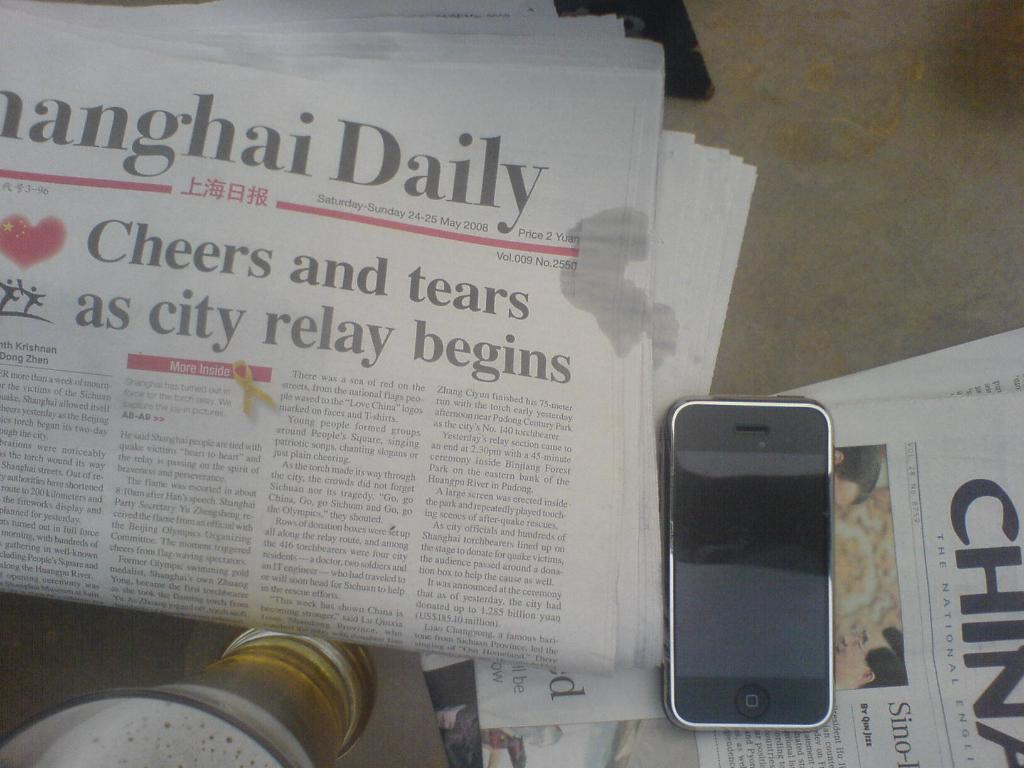<image>
Give a short and clear explanation of the subsequent image. an iphone is laying on top of a china newspaper 